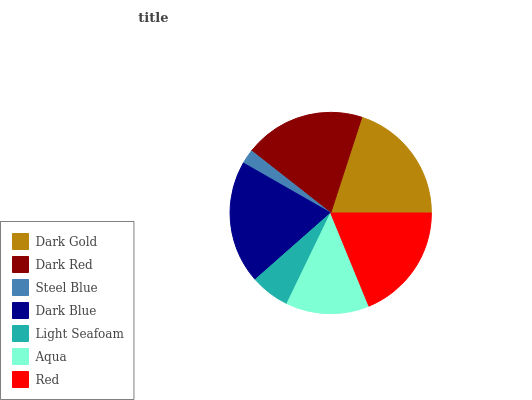Is Steel Blue the minimum?
Answer yes or no. Yes. Is Dark Gold the maximum?
Answer yes or no. Yes. Is Dark Red the minimum?
Answer yes or no. No. Is Dark Red the maximum?
Answer yes or no. No. Is Dark Gold greater than Dark Red?
Answer yes or no. Yes. Is Dark Red less than Dark Gold?
Answer yes or no. Yes. Is Dark Red greater than Dark Gold?
Answer yes or no. No. Is Dark Gold less than Dark Red?
Answer yes or no. No. Is Red the high median?
Answer yes or no. Yes. Is Red the low median?
Answer yes or no. Yes. Is Steel Blue the high median?
Answer yes or no. No. Is Light Seafoam the low median?
Answer yes or no. No. 